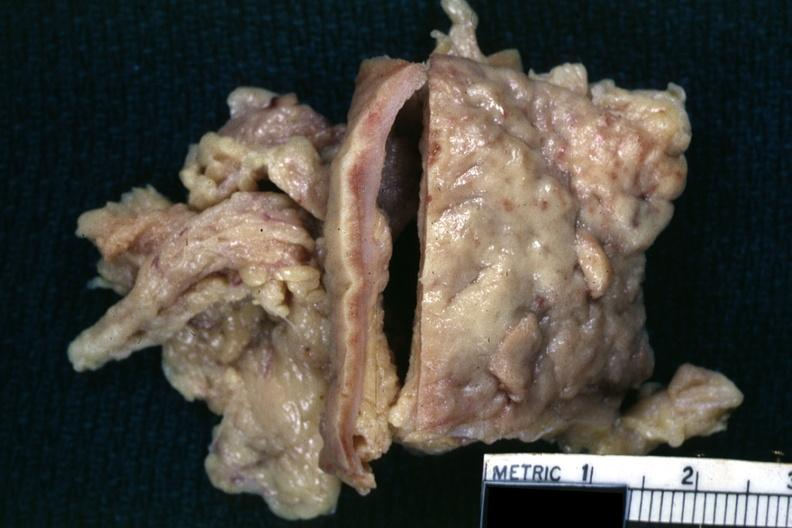what is present?
Answer the question using a single word or phrase. Omentum 